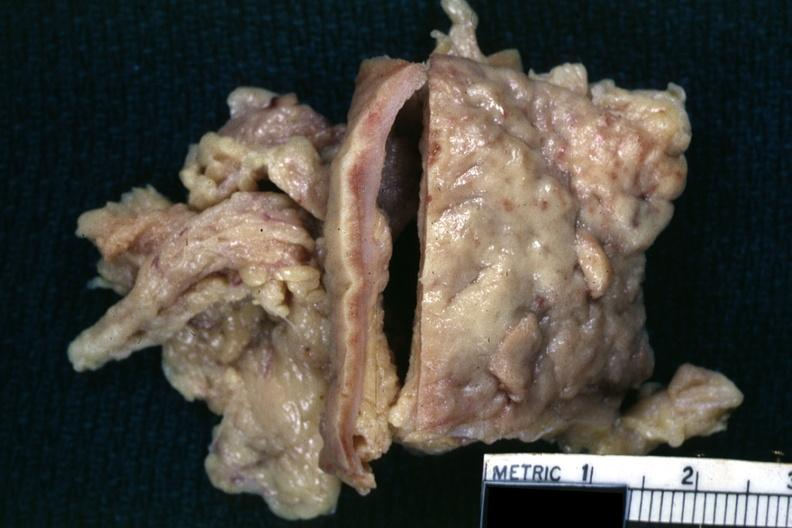what is present?
Answer the question using a single word or phrase. Omentum 